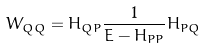<formula> <loc_0><loc_0><loc_500><loc_500>W _ { Q Q } = H _ { Q P } \frac { 1 } { E - H _ { P P } } H _ { P Q }</formula> 